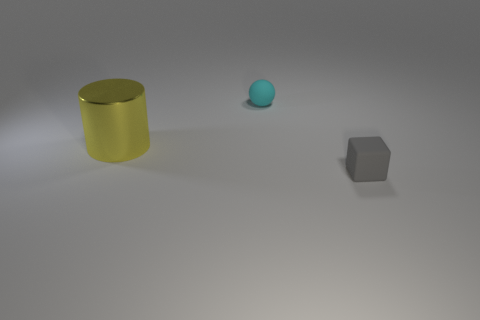Add 3 tiny purple balls. How many objects exist? 6 Subtract all blocks. How many objects are left? 2 Add 1 big metallic cylinders. How many big metallic cylinders exist? 2 Subtract 0 purple spheres. How many objects are left? 3 Subtract all gray things. Subtract all cyan rubber balls. How many objects are left? 1 Add 3 big yellow metallic cylinders. How many big yellow metallic cylinders are left? 4 